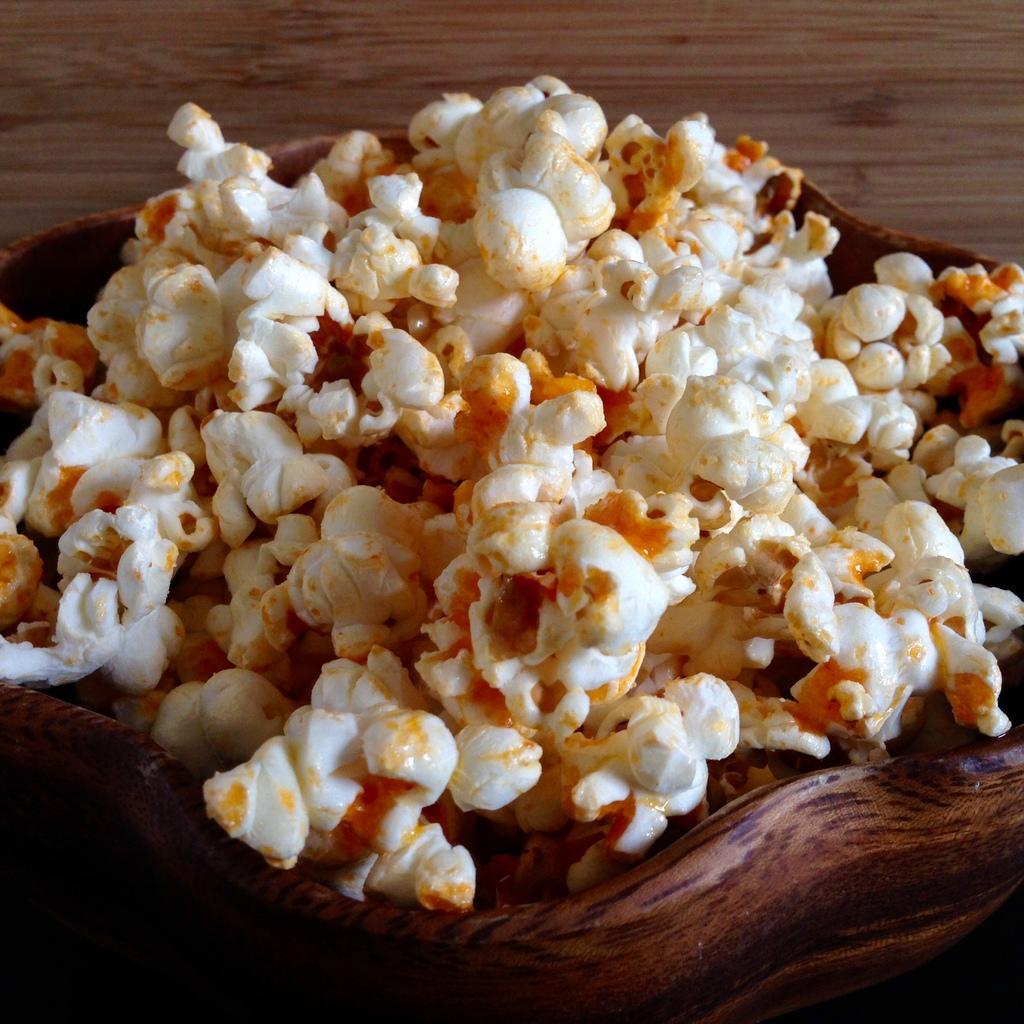Could you give a brief overview of what you see in this image? In the picture we can see pop corn which is in the wooden bowl and it is placed on the wooden plank. 